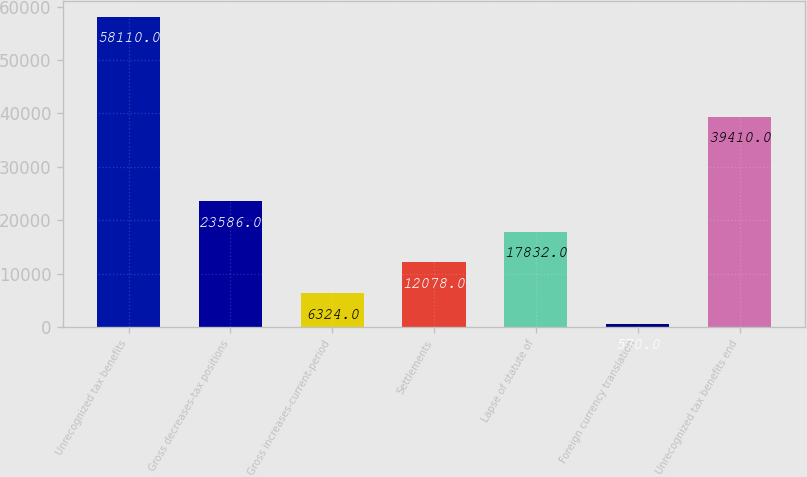<chart> <loc_0><loc_0><loc_500><loc_500><bar_chart><fcel>Unrecognized tax benefits<fcel>Gross decreases-tax positions<fcel>Gross increases-current-period<fcel>Settlements<fcel>Lapse of statute of<fcel>Foreign currency translation<fcel>Unrecognized tax benefits end<nl><fcel>58110<fcel>23586<fcel>6324<fcel>12078<fcel>17832<fcel>570<fcel>39410<nl></chart> 